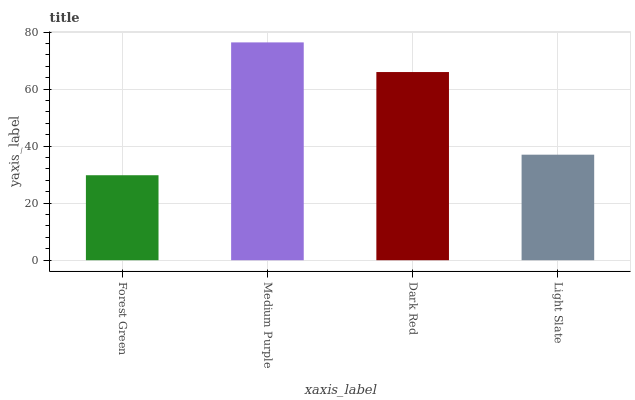Is Forest Green the minimum?
Answer yes or no. Yes. Is Medium Purple the maximum?
Answer yes or no. Yes. Is Dark Red the minimum?
Answer yes or no. No. Is Dark Red the maximum?
Answer yes or no. No. Is Medium Purple greater than Dark Red?
Answer yes or no. Yes. Is Dark Red less than Medium Purple?
Answer yes or no. Yes. Is Dark Red greater than Medium Purple?
Answer yes or no. No. Is Medium Purple less than Dark Red?
Answer yes or no. No. Is Dark Red the high median?
Answer yes or no. Yes. Is Light Slate the low median?
Answer yes or no. Yes. Is Light Slate the high median?
Answer yes or no. No. Is Medium Purple the low median?
Answer yes or no. No. 